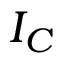Convert formula to latex. <formula><loc_0><loc_0><loc_500><loc_500>I _ { C }</formula> 